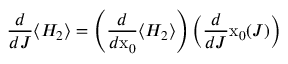<formula> <loc_0><loc_0><loc_500><loc_500>\frac { d } { d J } \langle H _ { 2 } \rangle = \left ( \frac { d } { d x _ { 0 } } \langle H _ { 2 } \rangle \right ) \left ( \frac { d } { d J } x _ { 0 } ( J ) \right )</formula> 